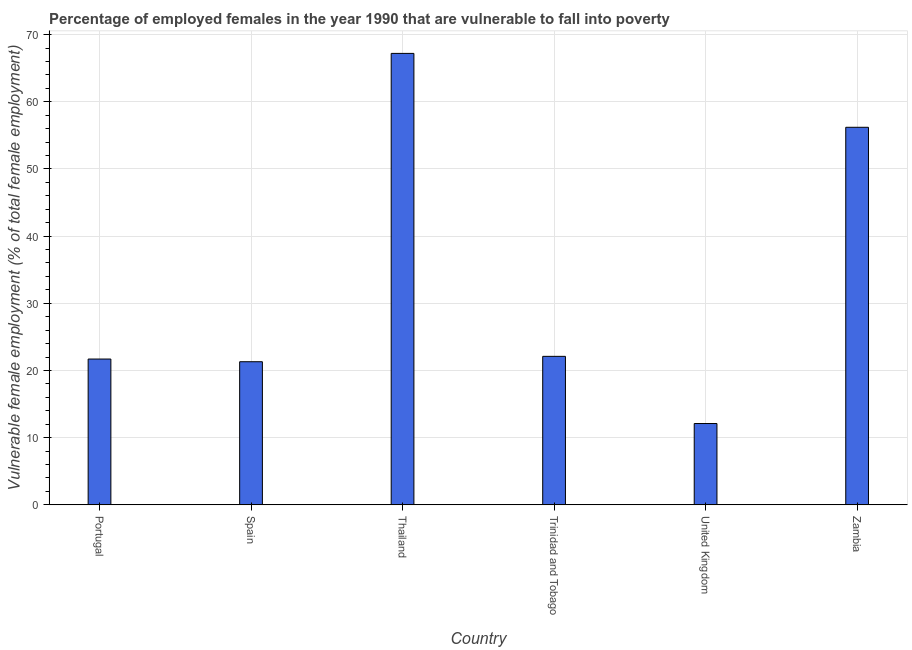Does the graph contain grids?
Offer a terse response. Yes. What is the title of the graph?
Your answer should be very brief. Percentage of employed females in the year 1990 that are vulnerable to fall into poverty. What is the label or title of the Y-axis?
Provide a short and direct response. Vulnerable female employment (% of total female employment). What is the percentage of employed females who are vulnerable to fall into poverty in United Kingdom?
Provide a short and direct response. 12.1. Across all countries, what is the maximum percentage of employed females who are vulnerable to fall into poverty?
Provide a short and direct response. 67.2. Across all countries, what is the minimum percentage of employed females who are vulnerable to fall into poverty?
Provide a succinct answer. 12.1. In which country was the percentage of employed females who are vulnerable to fall into poverty maximum?
Give a very brief answer. Thailand. What is the sum of the percentage of employed females who are vulnerable to fall into poverty?
Your answer should be very brief. 200.6. What is the difference between the percentage of employed females who are vulnerable to fall into poverty in Portugal and Spain?
Keep it short and to the point. 0.4. What is the average percentage of employed females who are vulnerable to fall into poverty per country?
Give a very brief answer. 33.43. What is the median percentage of employed females who are vulnerable to fall into poverty?
Offer a terse response. 21.9. In how many countries, is the percentage of employed females who are vulnerable to fall into poverty greater than 62 %?
Your response must be concise. 1. What is the ratio of the percentage of employed females who are vulnerable to fall into poverty in Thailand to that in Trinidad and Tobago?
Offer a very short reply. 3.04. Is the percentage of employed females who are vulnerable to fall into poverty in Portugal less than that in United Kingdom?
Provide a short and direct response. No. Is the difference between the percentage of employed females who are vulnerable to fall into poverty in Portugal and Thailand greater than the difference between any two countries?
Ensure brevity in your answer.  No. Is the sum of the percentage of employed females who are vulnerable to fall into poverty in Spain and Thailand greater than the maximum percentage of employed females who are vulnerable to fall into poverty across all countries?
Provide a short and direct response. Yes. What is the difference between the highest and the lowest percentage of employed females who are vulnerable to fall into poverty?
Your answer should be compact. 55.1. In how many countries, is the percentage of employed females who are vulnerable to fall into poverty greater than the average percentage of employed females who are vulnerable to fall into poverty taken over all countries?
Provide a succinct answer. 2. How many bars are there?
Your answer should be very brief. 6. Are all the bars in the graph horizontal?
Ensure brevity in your answer.  No. Are the values on the major ticks of Y-axis written in scientific E-notation?
Your response must be concise. No. What is the Vulnerable female employment (% of total female employment) in Portugal?
Ensure brevity in your answer.  21.7. What is the Vulnerable female employment (% of total female employment) of Spain?
Ensure brevity in your answer.  21.3. What is the Vulnerable female employment (% of total female employment) of Thailand?
Your answer should be compact. 67.2. What is the Vulnerable female employment (% of total female employment) of Trinidad and Tobago?
Your response must be concise. 22.1. What is the Vulnerable female employment (% of total female employment) of United Kingdom?
Your answer should be very brief. 12.1. What is the Vulnerable female employment (% of total female employment) of Zambia?
Your response must be concise. 56.2. What is the difference between the Vulnerable female employment (% of total female employment) in Portugal and Spain?
Your answer should be compact. 0.4. What is the difference between the Vulnerable female employment (% of total female employment) in Portugal and Thailand?
Offer a very short reply. -45.5. What is the difference between the Vulnerable female employment (% of total female employment) in Portugal and United Kingdom?
Provide a short and direct response. 9.6. What is the difference between the Vulnerable female employment (% of total female employment) in Portugal and Zambia?
Provide a succinct answer. -34.5. What is the difference between the Vulnerable female employment (% of total female employment) in Spain and Thailand?
Provide a succinct answer. -45.9. What is the difference between the Vulnerable female employment (% of total female employment) in Spain and Trinidad and Tobago?
Give a very brief answer. -0.8. What is the difference between the Vulnerable female employment (% of total female employment) in Spain and United Kingdom?
Ensure brevity in your answer.  9.2. What is the difference between the Vulnerable female employment (% of total female employment) in Spain and Zambia?
Offer a terse response. -34.9. What is the difference between the Vulnerable female employment (% of total female employment) in Thailand and Trinidad and Tobago?
Offer a very short reply. 45.1. What is the difference between the Vulnerable female employment (% of total female employment) in Thailand and United Kingdom?
Your response must be concise. 55.1. What is the difference between the Vulnerable female employment (% of total female employment) in Trinidad and Tobago and Zambia?
Your answer should be very brief. -34.1. What is the difference between the Vulnerable female employment (% of total female employment) in United Kingdom and Zambia?
Make the answer very short. -44.1. What is the ratio of the Vulnerable female employment (% of total female employment) in Portugal to that in Thailand?
Ensure brevity in your answer.  0.32. What is the ratio of the Vulnerable female employment (% of total female employment) in Portugal to that in Trinidad and Tobago?
Your answer should be compact. 0.98. What is the ratio of the Vulnerable female employment (% of total female employment) in Portugal to that in United Kingdom?
Make the answer very short. 1.79. What is the ratio of the Vulnerable female employment (% of total female employment) in Portugal to that in Zambia?
Ensure brevity in your answer.  0.39. What is the ratio of the Vulnerable female employment (% of total female employment) in Spain to that in Thailand?
Keep it short and to the point. 0.32. What is the ratio of the Vulnerable female employment (% of total female employment) in Spain to that in Trinidad and Tobago?
Your answer should be compact. 0.96. What is the ratio of the Vulnerable female employment (% of total female employment) in Spain to that in United Kingdom?
Provide a short and direct response. 1.76. What is the ratio of the Vulnerable female employment (% of total female employment) in Spain to that in Zambia?
Keep it short and to the point. 0.38. What is the ratio of the Vulnerable female employment (% of total female employment) in Thailand to that in Trinidad and Tobago?
Provide a short and direct response. 3.04. What is the ratio of the Vulnerable female employment (% of total female employment) in Thailand to that in United Kingdom?
Make the answer very short. 5.55. What is the ratio of the Vulnerable female employment (% of total female employment) in Thailand to that in Zambia?
Offer a terse response. 1.2. What is the ratio of the Vulnerable female employment (% of total female employment) in Trinidad and Tobago to that in United Kingdom?
Make the answer very short. 1.83. What is the ratio of the Vulnerable female employment (% of total female employment) in Trinidad and Tobago to that in Zambia?
Offer a terse response. 0.39. What is the ratio of the Vulnerable female employment (% of total female employment) in United Kingdom to that in Zambia?
Keep it short and to the point. 0.21. 